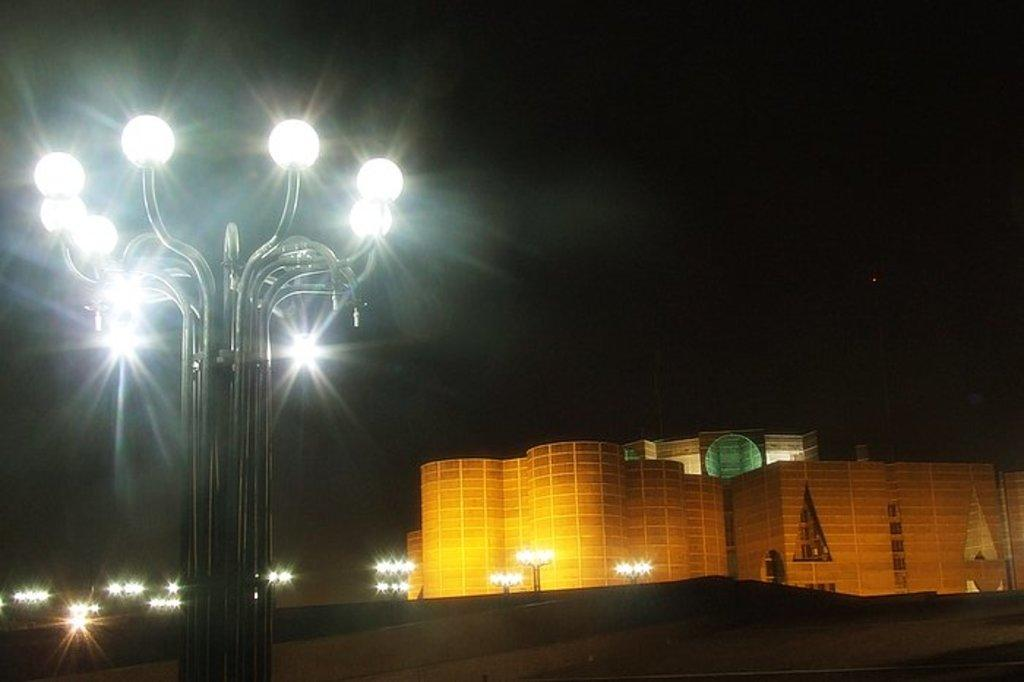What structures are present in the image? There are light poles in the image. What can be seen in the distance in the image? There are buildings in the background of the image. What is the color of the sky in the image? The sky appears to be black in color. Can you see any friends hanging out under the light poles in the image? There is no indication of friends or any people in the image; it only shows light poles and buildings in the background. 